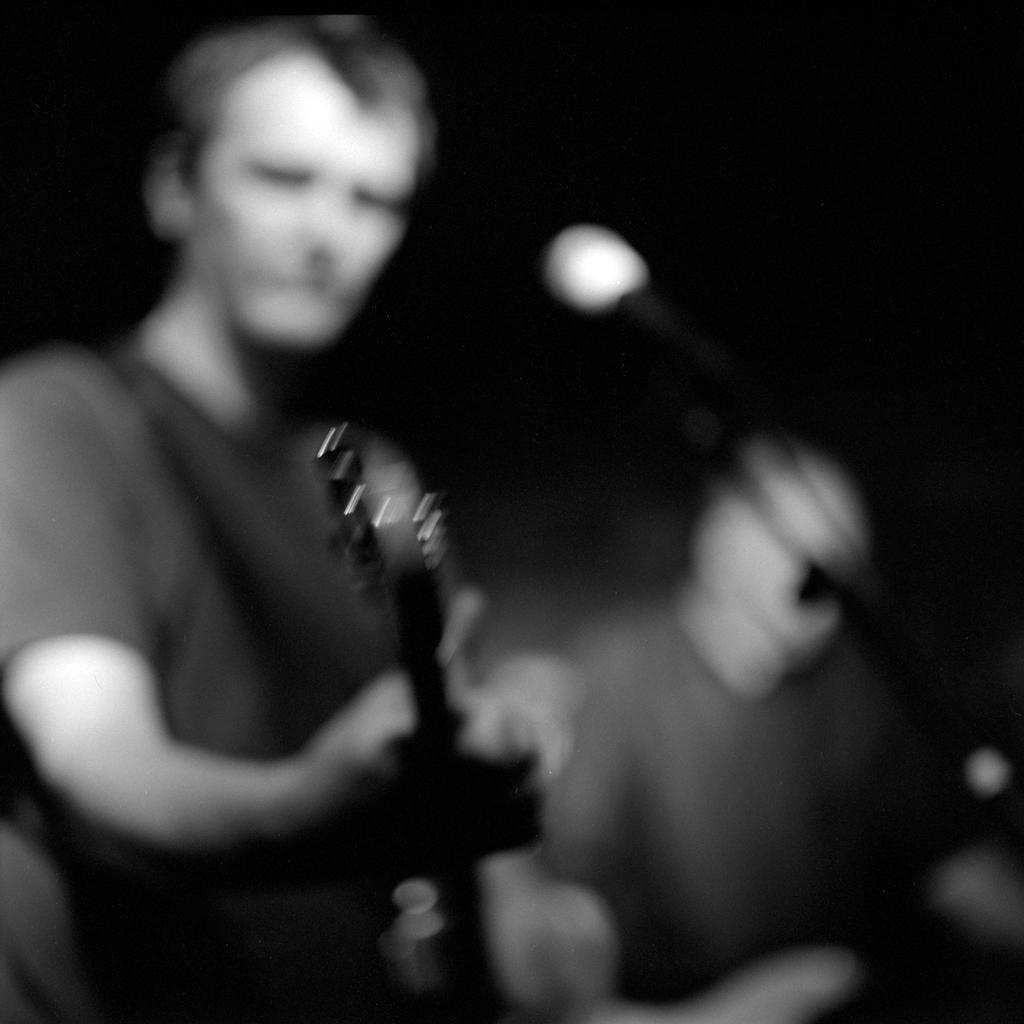Describe this image in one or two sentences. This is a black and white picture. Here we can see two persons. He is playing guitar and this is mike. 